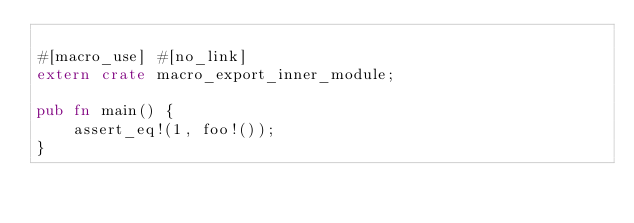Convert code to text. <code><loc_0><loc_0><loc_500><loc_500><_Rust_>
#[macro_use] #[no_link]
extern crate macro_export_inner_module;

pub fn main() {
    assert_eq!(1, foo!());
}
</code> 